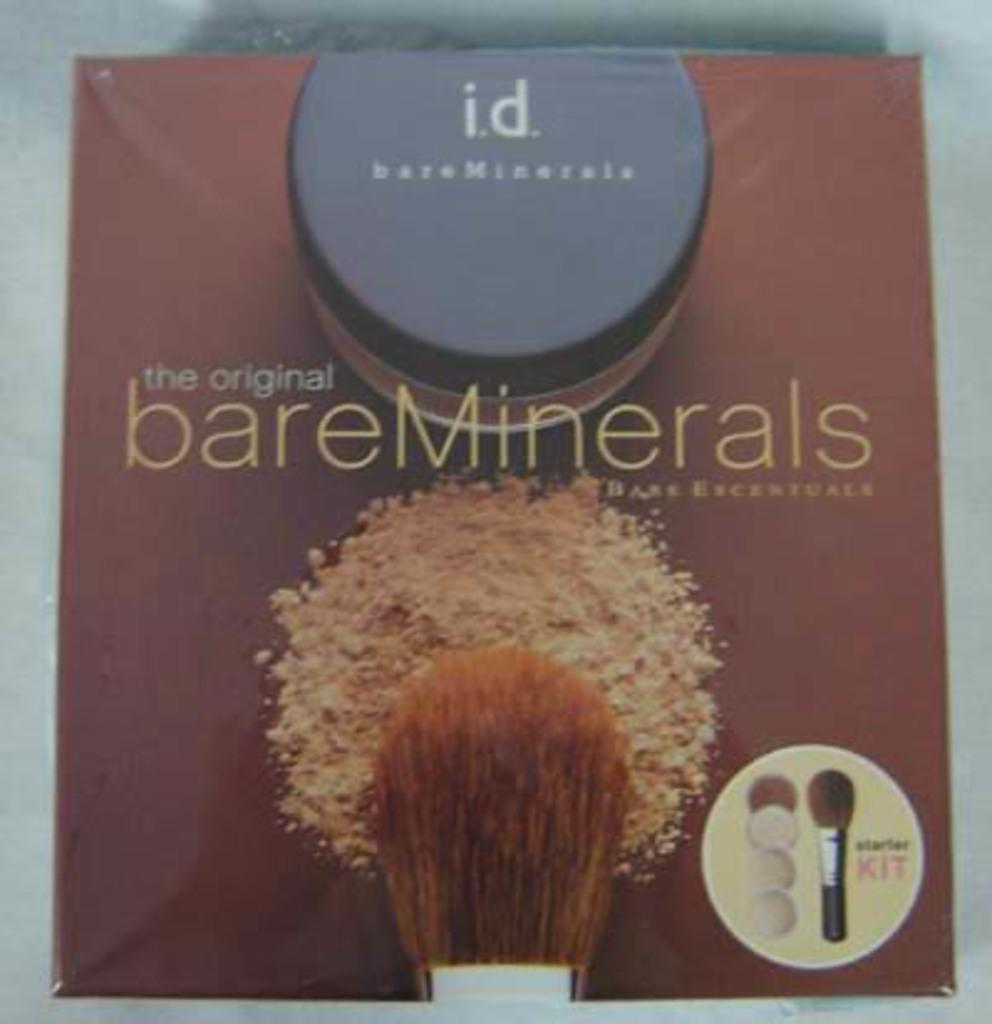<image>
Write a terse but informative summary of the picture. Bare Minerals starter kit including makeup and brush/ 